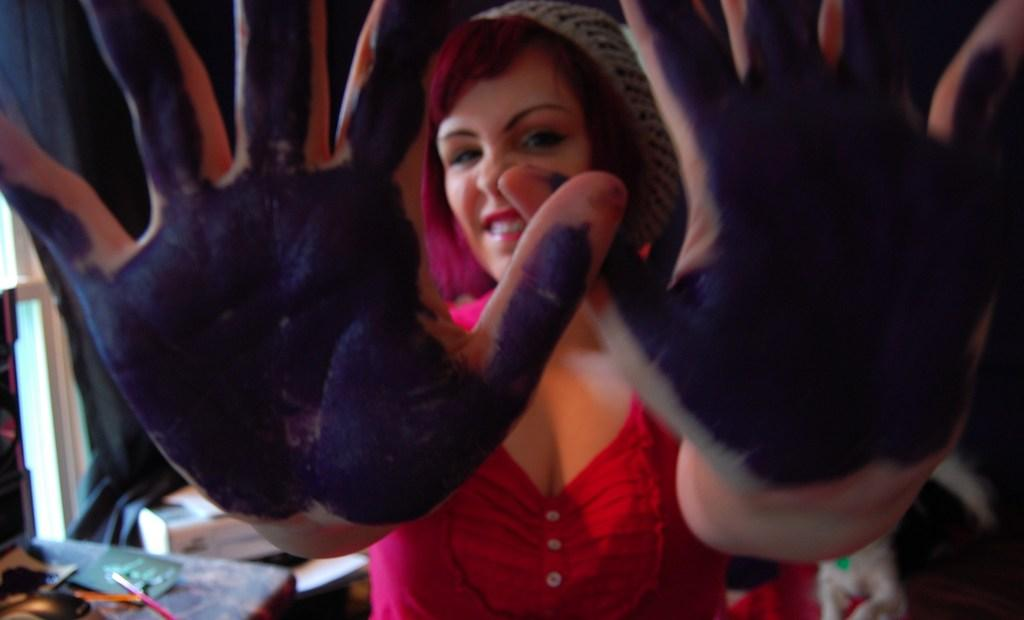Who is the main subject in the image? There is a woman in the image. What is unique about the woman's hands? The woman has colors on the palm of her hands. Can you describe the background of the image? The background of the image is not clear, but there are objects visible in the background. What type of architectural feature can be seen in the background? There is a window in the background. What type of fruit is the woman holding in the image? There is no fruit visible in the image; the woman has colors on her palms. What experience does the woman have with parenting in the image? There is no information about the woman's parenting experience in the image. 